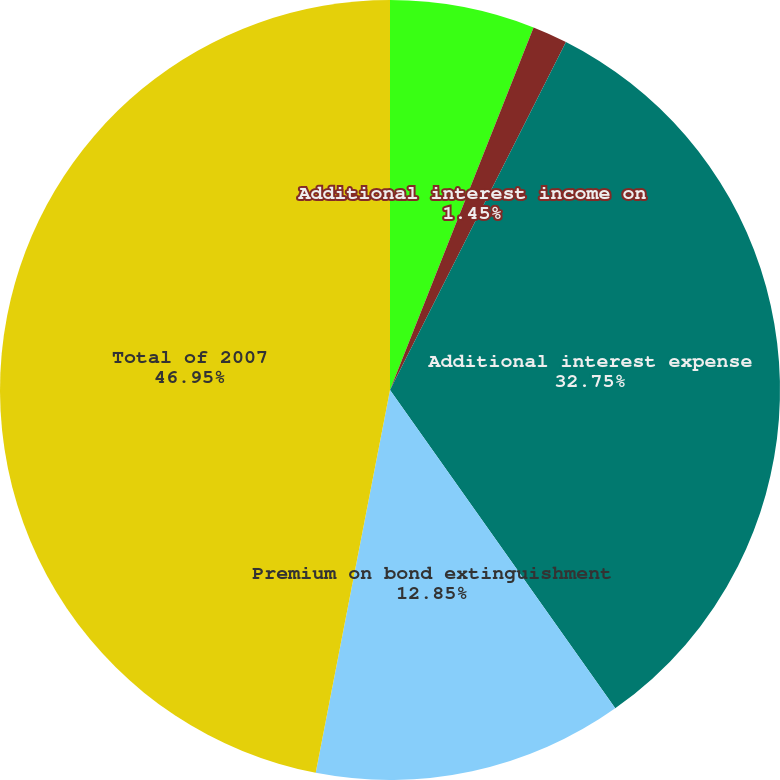Convert chart to OTSL. <chart><loc_0><loc_0><loc_500><loc_500><pie_chart><fcel>General and administrative<fcel>Additional interest income on<fcel>Additional interest expense<fcel>Premium on bond extinguishment<fcel>Total of 2007<nl><fcel>6.0%<fcel>1.45%<fcel>32.75%<fcel>12.85%<fcel>46.95%<nl></chart> 